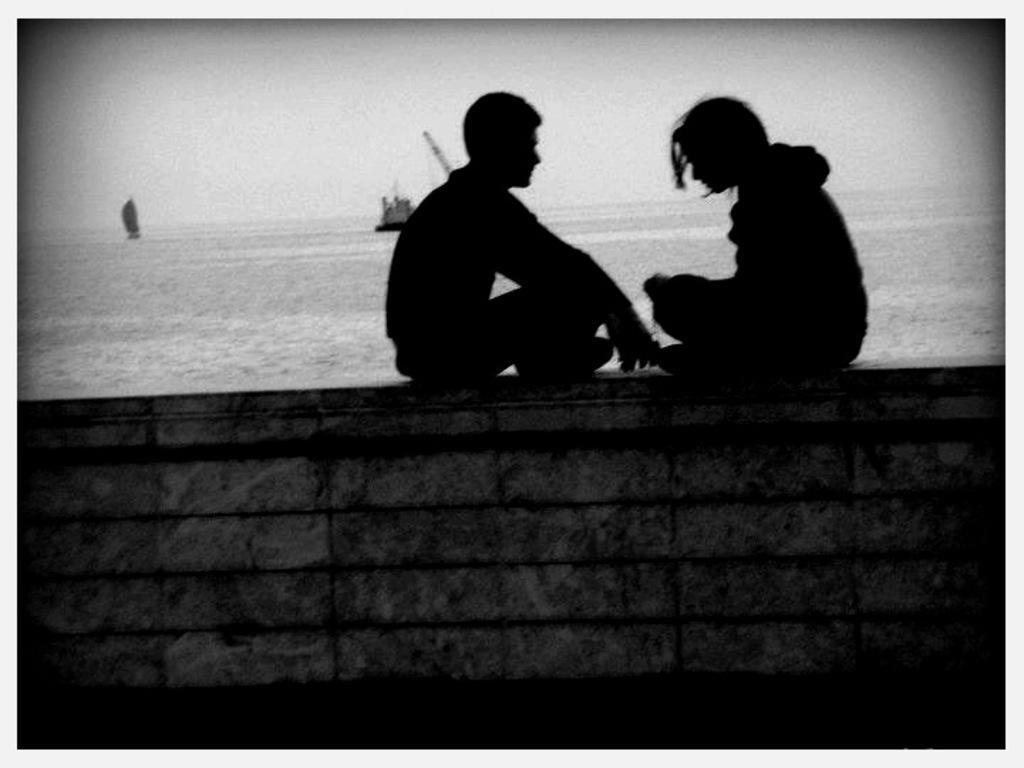Please provide a concise description of this image. In the image I can see two people are sitting on the wall. In the background I can see boats on the water and the sky. This image is black and white in color. 